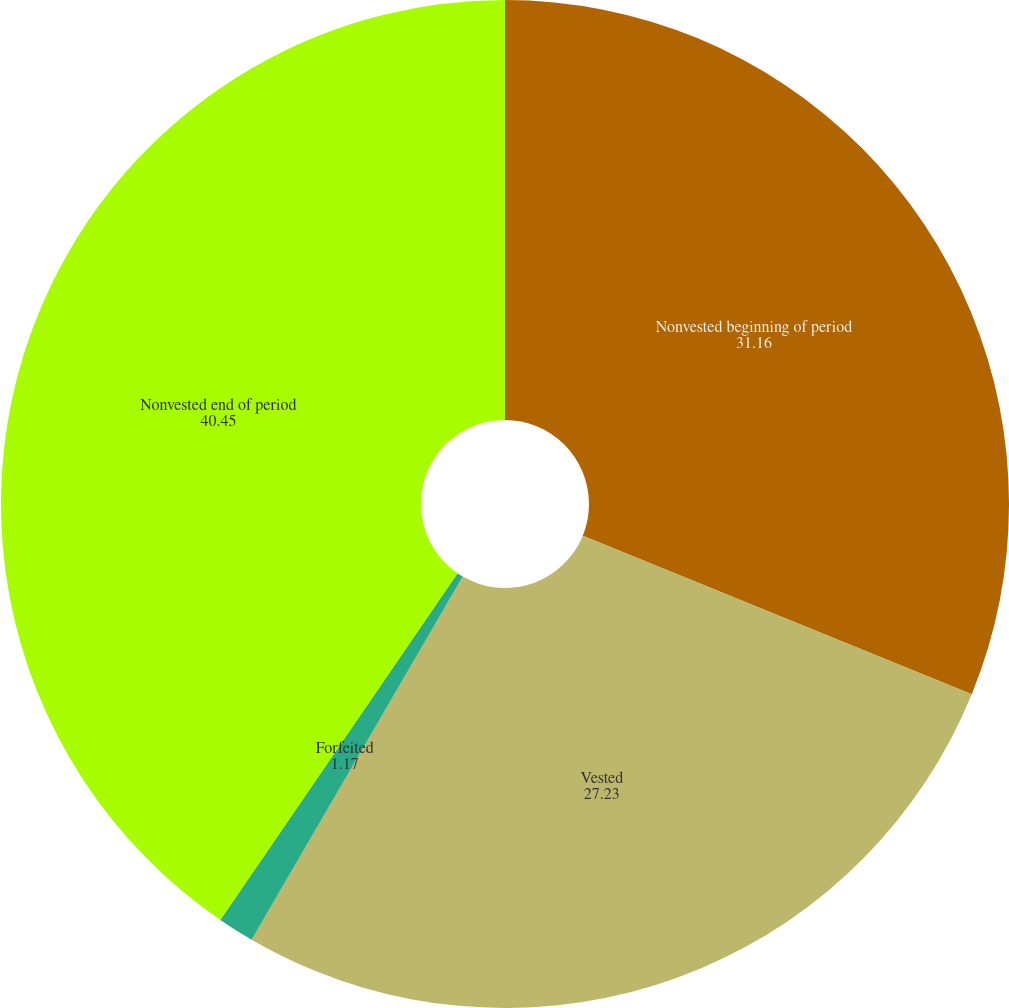<chart> <loc_0><loc_0><loc_500><loc_500><pie_chart><fcel>Nonvested beginning of period<fcel>Vested<fcel>Forfeited<fcel>Nonvested end of period<nl><fcel>31.16%<fcel>27.23%<fcel>1.17%<fcel>40.45%<nl></chart> 